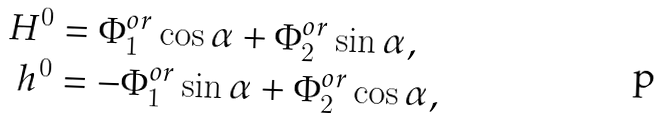<formula> <loc_0><loc_0><loc_500><loc_500>H ^ { 0 } & = \Phi _ { 1 } ^ { o r } \cos \alpha + \Phi _ { 2 } ^ { o r } \sin \alpha , \\ h ^ { 0 } & = - \Phi _ { 1 } ^ { o r } \sin \alpha + \Phi _ { 2 } ^ { o r } \cos \alpha ,</formula> 